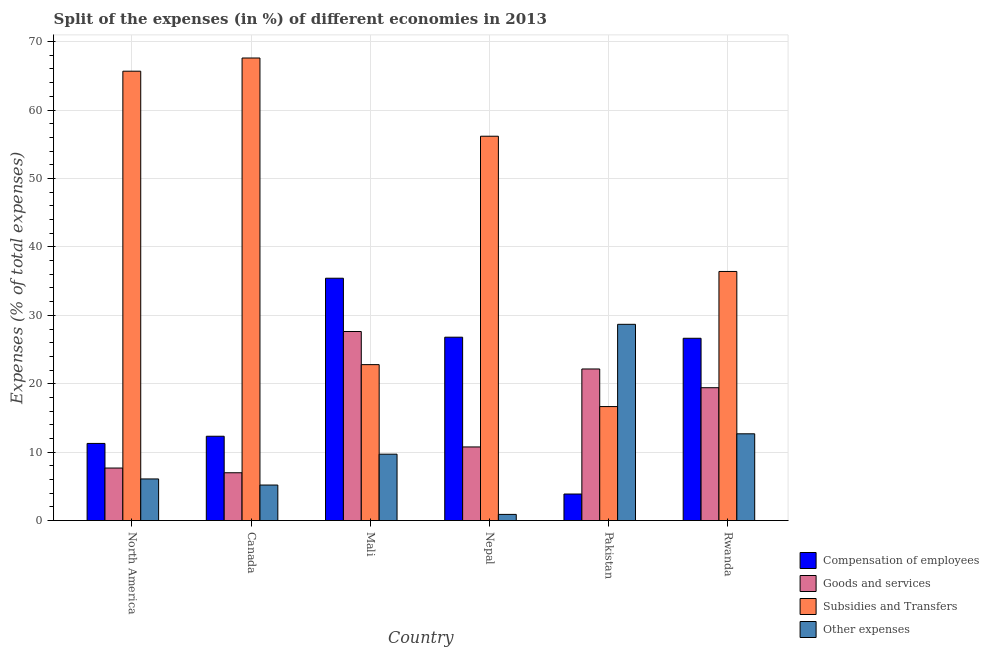How many different coloured bars are there?
Your response must be concise. 4. How many groups of bars are there?
Your response must be concise. 6. Are the number of bars per tick equal to the number of legend labels?
Offer a very short reply. Yes. How many bars are there on the 2nd tick from the left?
Provide a succinct answer. 4. In how many cases, is the number of bars for a given country not equal to the number of legend labels?
Provide a succinct answer. 0. What is the percentage of amount spent on subsidies in North America?
Your answer should be very brief. 65.68. Across all countries, what is the maximum percentage of amount spent on goods and services?
Your answer should be very brief. 27.63. Across all countries, what is the minimum percentage of amount spent on other expenses?
Make the answer very short. 0.9. In which country was the percentage of amount spent on compensation of employees maximum?
Offer a terse response. Mali. What is the total percentage of amount spent on other expenses in the graph?
Make the answer very short. 63.26. What is the difference between the percentage of amount spent on goods and services in Mali and that in North America?
Provide a short and direct response. 19.95. What is the difference between the percentage of amount spent on compensation of employees in Canada and the percentage of amount spent on subsidies in Pakistan?
Your response must be concise. -4.34. What is the average percentage of amount spent on goods and services per country?
Offer a very short reply. 15.77. What is the difference between the percentage of amount spent on other expenses and percentage of amount spent on compensation of employees in Canada?
Keep it short and to the point. -7.13. In how many countries, is the percentage of amount spent on goods and services greater than 46 %?
Your answer should be compact. 0. What is the ratio of the percentage of amount spent on goods and services in Canada to that in Pakistan?
Ensure brevity in your answer.  0.32. Is the difference between the percentage of amount spent on compensation of employees in Canada and Mali greater than the difference between the percentage of amount spent on goods and services in Canada and Mali?
Provide a succinct answer. No. What is the difference between the highest and the second highest percentage of amount spent on subsidies?
Provide a short and direct response. 1.93. What is the difference between the highest and the lowest percentage of amount spent on subsidies?
Make the answer very short. 50.94. Is the sum of the percentage of amount spent on other expenses in Mali and North America greater than the maximum percentage of amount spent on goods and services across all countries?
Give a very brief answer. No. Is it the case that in every country, the sum of the percentage of amount spent on compensation of employees and percentage of amount spent on other expenses is greater than the sum of percentage of amount spent on goods and services and percentage of amount spent on subsidies?
Your response must be concise. No. What does the 4th bar from the left in Rwanda represents?
Your answer should be compact. Other expenses. What does the 2nd bar from the right in Pakistan represents?
Your answer should be very brief. Subsidies and Transfers. Is it the case that in every country, the sum of the percentage of amount spent on compensation of employees and percentage of amount spent on goods and services is greater than the percentage of amount spent on subsidies?
Provide a succinct answer. No. Are all the bars in the graph horizontal?
Provide a succinct answer. No. What is the difference between two consecutive major ticks on the Y-axis?
Your answer should be very brief. 10. Does the graph contain any zero values?
Your response must be concise. No. How are the legend labels stacked?
Give a very brief answer. Vertical. What is the title of the graph?
Offer a terse response. Split of the expenses (in %) of different economies in 2013. What is the label or title of the X-axis?
Your response must be concise. Country. What is the label or title of the Y-axis?
Ensure brevity in your answer.  Expenses (% of total expenses). What is the Expenses (% of total expenses) of Compensation of employees in North America?
Offer a terse response. 11.28. What is the Expenses (% of total expenses) of Goods and services in North America?
Make the answer very short. 7.68. What is the Expenses (% of total expenses) in Subsidies and Transfers in North America?
Keep it short and to the point. 65.68. What is the Expenses (% of total expenses) of Other expenses in North America?
Provide a short and direct response. 6.09. What is the Expenses (% of total expenses) in Compensation of employees in Canada?
Your response must be concise. 12.33. What is the Expenses (% of total expenses) in Goods and services in Canada?
Keep it short and to the point. 6.99. What is the Expenses (% of total expenses) of Subsidies and Transfers in Canada?
Your answer should be very brief. 67.61. What is the Expenses (% of total expenses) in Other expenses in Canada?
Offer a terse response. 5.2. What is the Expenses (% of total expenses) of Compensation of employees in Mali?
Offer a terse response. 35.42. What is the Expenses (% of total expenses) in Goods and services in Mali?
Your response must be concise. 27.63. What is the Expenses (% of total expenses) of Subsidies and Transfers in Mali?
Keep it short and to the point. 22.79. What is the Expenses (% of total expenses) of Other expenses in Mali?
Make the answer very short. 9.71. What is the Expenses (% of total expenses) of Compensation of employees in Nepal?
Ensure brevity in your answer.  26.8. What is the Expenses (% of total expenses) of Goods and services in Nepal?
Provide a succinct answer. 10.76. What is the Expenses (% of total expenses) of Subsidies and Transfers in Nepal?
Offer a very short reply. 56.17. What is the Expenses (% of total expenses) of Other expenses in Nepal?
Your answer should be compact. 0.9. What is the Expenses (% of total expenses) of Compensation of employees in Pakistan?
Offer a terse response. 3.88. What is the Expenses (% of total expenses) of Goods and services in Pakistan?
Your response must be concise. 22.16. What is the Expenses (% of total expenses) in Subsidies and Transfers in Pakistan?
Offer a terse response. 16.66. What is the Expenses (% of total expenses) of Other expenses in Pakistan?
Your answer should be very brief. 28.68. What is the Expenses (% of total expenses) of Compensation of employees in Rwanda?
Provide a short and direct response. 26.64. What is the Expenses (% of total expenses) in Goods and services in Rwanda?
Keep it short and to the point. 19.42. What is the Expenses (% of total expenses) of Subsidies and Transfers in Rwanda?
Your answer should be very brief. 36.41. What is the Expenses (% of total expenses) of Other expenses in Rwanda?
Provide a short and direct response. 12.68. Across all countries, what is the maximum Expenses (% of total expenses) of Compensation of employees?
Offer a terse response. 35.42. Across all countries, what is the maximum Expenses (% of total expenses) of Goods and services?
Your answer should be compact. 27.63. Across all countries, what is the maximum Expenses (% of total expenses) in Subsidies and Transfers?
Your answer should be compact. 67.61. Across all countries, what is the maximum Expenses (% of total expenses) in Other expenses?
Your answer should be compact. 28.68. Across all countries, what is the minimum Expenses (% of total expenses) in Compensation of employees?
Keep it short and to the point. 3.88. Across all countries, what is the minimum Expenses (% of total expenses) in Goods and services?
Provide a succinct answer. 6.99. Across all countries, what is the minimum Expenses (% of total expenses) in Subsidies and Transfers?
Keep it short and to the point. 16.66. Across all countries, what is the minimum Expenses (% of total expenses) in Other expenses?
Give a very brief answer. 0.9. What is the total Expenses (% of total expenses) of Compensation of employees in the graph?
Your answer should be very brief. 116.36. What is the total Expenses (% of total expenses) of Goods and services in the graph?
Provide a succinct answer. 94.65. What is the total Expenses (% of total expenses) of Subsidies and Transfers in the graph?
Your response must be concise. 265.33. What is the total Expenses (% of total expenses) of Other expenses in the graph?
Your response must be concise. 63.26. What is the difference between the Expenses (% of total expenses) in Compensation of employees in North America and that in Canada?
Provide a short and direct response. -1.05. What is the difference between the Expenses (% of total expenses) in Goods and services in North America and that in Canada?
Offer a very short reply. 0.69. What is the difference between the Expenses (% of total expenses) of Subsidies and Transfers in North America and that in Canada?
Give a very brief answer. -1.93. What is the difference between the Expenses (% of total expenses) in Other expenses in North America and that in Canada?
Keep it short and to the point. 0.89. What is the difference between the Expenses (% of total expenses) in Compensation of employees in North America and that in Mali?
Your answer should be compact. -24.14. What is the difference between the Expenses (% of total expenses) of Goods and services in North America and that in Mali?
Offer a terse response. -19.95. What is the difference between the Expenses (% of total expenses) of Subsidies and Transfers in North America and that in Mali?
Offer a terse response. 42.89. What is the difference between the Expenses (% of total expenses) in Other expenses in North America and that in Mali?
Your response must be concise. -3.62. What is the difference between the Expenses (% of total expenses) in Compensation of employees in North America and that in Nepal?
Give a very brief answer. -15.53. What is the difference between the Expenses (% of total expenses) in Goods and services in North America and that in Nepal?
Ensure brevity in your answer.  -3.08. What is the difference between the Expenses (% of total expenses) in Subsidies and Transfers in North America and that in Nepal?
Your answer should be compact. 9.5. What is the difference between the Expenses (% of total expenses) in Other expenses in North America and that in Nepal?
Give a very brief answer. 5.18. What is the difference between the Expenses (% of total expenses) of Compensation of employees in North America and that in Pakistan?
Keep it short and to the point. 7.39. What is the difference between the Expenses (% of total expenses) of Goods and services in North America and that in Pakistan?
Your response must be concise. -14.48. What is the difference between the Expenses (% of total expenses) of Subsidies and Transfers in North America and that in Pakistan?
Provide a short and direct response. 49.01. What is the difference between the Expenses (% of total expenses) of Other expenses in North America and that in Pakistan?
Keep it short and to the point. -22.6. What is the difference between the Expenses (% of total expenses) in Compensation of employees in North America and that in Rwanda?
Make the answer very short. -15.37. What is the difference between the Expenses (% of total expenses) in Goods and services in North America and that in Rwanda?
Offer a terse response. -11.74. What is the difference between the Expenses (% of total expenses) of Subsidies and Transfers in North America and that in Rwanda?
Your answer should be very brief. 29.27. What is the difference between the Expenses (% of total expenses) in Other expenses in North America and that in Rwanda?
Provide a succinct answer. -6.6. What is the difference between the Expenses (% of total expenses) in Compensation of employees in Canada and that in Mali?
Make the answer very short. -23.09. What is the difference between the Expenses (% of total expenses) in Goods and services in Canada and that in Mali?
Your response must be concise. -20.64. What is the difference between the Expenses (% of total expenses) in Subsidies and Transfers in Canada and that in Mali?
Offer a terse response. 44.81. What is the difference between the Expenses (% of total expenses) in Other expenses in Canada and that in Mali?
Offer a very short reply. -4.51. What is the difference between the Expenses (% of total expenses) in Compensation of employees in Canada and that in Nepal?
Make the answer very short. -14.48. What is the difference between the Expenses (% of total expenses) of Goods and services in Canada and that in Nepal?
Your answer should be compact. -3.77. What is the difference between the Expenses (% of total expenses) of Subsidies and Transfers in Canada and that in Nepal?
Provide a succinct answer. 11.43. What is the difference between the Expenses (% of total expenses) in Other expenses in Canada and that in Nepal?
Your answer should be very brief. 4.29. What is the difference between the Expenses (% of total expenses) in Compensation of employees in Canada and that in Pakistan?
Give a very brief answer. 8.44. What is the difference between the Expenses (% of total expenses) in Goods and services in Canada and that in Pakistan?
Provide a succinct answer. -15.17. What is the difference between the Expenses (% of total expenses) in Subsidies and Transfers in Canada and that in Pakistan?
Provide a short and direct response. 50.94. What is the difference between the Expenses (% of total expenses) of Other expenses in Canada and that in Pakistan?
Provide a succinct answer. -23.49. What is the difference between the Expenses (% of total expenses) in Compensation of employees in Canada and that in Rwanda?
Your answer should be very brief. -14.32. What is the difference between the Expenses (% of total expenses) of Goods and services in Canada and that in Rwanda?
Give a very brief answer. -12.43. What is the difference between the Expenses (% of total expenses) in Subsidies and Transfers in Canada and that in Rwanda?
Offer a terse response. 31.2. What is the difference between the Expenses (% of total expenses) of Other expenses in Canada and that in Rwanda?
Offer a very short reply. -7.49. What is the difference between the Expenses (% of total expenses) of Compensation of employees in Mali and that in Nepal?
Offer a terse response. 8.62. What is the difference between the Expenses (% of total expenses) of Goods and services in Mali and that in Nepal?
Make the answer very short. 16.87. What is the difference between the Expenses (% of total expenses) of Subsidies and Transfers in Mali and that in Nepal?
Your answer should be compact. -33.38. What is the difference between the Expenses (% of total expenses) of Other expenses in Mali and that in Nepal?
Make the answer very short. 8.8. What is the difference between the Expenses (% of total expenses) in Compensation of employees in Mali and that in Pakistan?
Your response must be concise. 31.54. What is the difference between the Expenses (% of total expenses) in Goods and services in Mali and that in Pakistan?
Your answer should be compact. 5.48. What is the difference between the Expenses (% of total expenses) of Subsidies and Transfers in Mali and that in Pakistan?
Provide a short and direct response. 6.13. What is the difference between the Expenses (% of total expenses) of Other expenses in Mali and that in Pakistan?
Your answer should be very brief. -18.98. What is the difference between the Expenses (% of total expenses) of Compensation of employees in Mali and that in Rwanda?
Ensure brevity in your answer.  8.78. What is the difference between the Expenses (% of total expenses) of Goods and services in Mali and that in Rwanda?
Make the answer very short. 8.21. What is the difference between the Expenses (% of total expenses) in Subsidies and Transfers in Mali and that in Rwanda?
Offer a terse response. -13.62. What is the difference between the Expenses (% of total expenses) of Other expenses in Mali and that in Rwanda?
Offer a terse response. -2.98. What is the difference between the Expenses (% of total expenses) of Compensation of employees in Nepal and that in Pakistan?
Ensure brevity in your answer.  22.92. What is the difference between the Expenses (% of total expenses) in Goods and services in Nepal and that in Pakistan?
Your response must be concise. -11.39. What is the difference between the Expenses (% of total expenses) of Subsidies and Transfers in Nepal and that in Pakistan?
Your response must be concise. 39.51. What is the difference between the Expenses (% of total expenses) in Other expenses in Nepal and that in Pakistan?
Provide a succinct answer. -27.78. What is the difference between the Expenses (% of total expenses) in Compensation of employees in Nepal and that in Rwanda?
Give a very brief answer. 0.16. What is the difference between the Expenses (% of total expenses) of Goods and services in Nepal and that in Rwanda?
Provide a short and direct response. -8.66. What is the difference between the Expenses (% of total expenses) of Subsidies and Transfers in Nepal and that in Rwanda?
Make the answer very short. 19.77. What is the difference between the Expenses (% of total expenses) of Other expenses in Nepal and that in Rwanda?
Provide a short and direct response. -11.78. What is the difference between the Expenses (% of total expenses) of Compensation of employees in Pakistan and that in Rwanda?
Your answer should be compact. -22.76. What is the difference between the Expenses (% of total expenses) of Goods and services in Pakistan and that in Rwanda?
Give a very brief answer. 2.74. What is the difference between the Expenses (% of total expenses) of Subsidies and Transfers in Pakistan and that in Rwanda?
Make the answer very short. -19.74. What is the difference between the Expenses (% of total expenses) of Other expenses in Pakistan and that in Rwanda?
Ensure brevity in your answer.  16. What is the difference between the Expenses (% of total expenses) in Compensation of employees in North America and the Expenses (% of total expenses) in Goods and services in Canada?
Keep it short and to the point. 4.29. What is the difference between the Expenses (% of total expenses) of Compensation of employees in North America and the Expenses (% of total expenses) of Subsidies and Transfers in Canada?
Ensure brevity in your answer.  -56.33. What is the difference between the Expenses (% of total expenses) of Compensation of employees in North America and the Expenses (% of total expenses) of Other expenses in Canada?
Offer a very short reply. 6.08. What is the difference between the Expenses (% of total expenses) in Goods and services in North America and the Expenses (% of total expenses) in Subsidies and Transfers in Canada?
Offer a very short reply. -59.92. What is the difference between the Expenses (% of total expenses) of Goods and services in North America and the Expenses (% of total expenses) of Other expenses in Canada?
Ensure brevity in your answer.  2.48. What is the difference between the Expenses (% of total expenses) in Subsidies and Transfers in North America and the Expenses (% of total expenses) in Other expenses in Canada?
Give a very brief answer. 60.48. What is the difference between the Expenses (% of total expenses) of Compensation of employees in North America and the Expenses (% of total expenses) of Goods and services in Mali?
Your answer should be compact. -16.36. What is the difference between the Expenses (% of total expenses) in Compensation of employees in North America and the Expenses (% of total expenses) in Subsidies and Transfers in Mali?
Your response must be concise. -11.51. What is the difference between the Expenses (% of total expenses) in Compensation of employees in North America and the Expenses (% of total expenses) in Other expenses in Mali?
Make the answer very short. 1.57. What is the difference between the Expenses (% of total expenses) of Goods and services in North America and the Expenses (% of total expenses) of Subsidies and Transfers in Mali?
Give a very brief answer. -15.11. What is the difference between the Expenses (% of total expenses) in Goods and services in North America and the Expenses (% of total expenses) in Other expenses in Mali?
Give a very brief answer. -2.02. What is the difference between the Expenses (% of total expenses) of Subsidies and Transfers in North America and the Expenses (% of total expenses) of Other expenses in Mali?
Ensure brevity in your answer.  55.97. What is the difference between the Expenses (% of total expenses) in Compensation of employees in North America and the Expenses (% of total expenses) in Goods and services in Nepal?
Make the answer very short. 0.51. What is the difference between the Expenses (% of total expenses) in Compensation of employees in North America and the Expenses (% of total expenses) in Subsidies and Transfers in Nepal?
Ensure brevity in your answer.  -44.9. What is the difference between the Expenses (% of total expenses) of Compensation of employees in North America and the Expenses (% of total expenses) of Other expenses in Nepal?
Your answer should be very brief. 10.37. What is the difference between the Expenses (% of total expenses) in Goods and services in North America and the Expenses (% of total expenses) in Subsidies and Transfers in Nepal?
Ensure brevity in your answer.  -48.49. What is the difference between the Expenses (% of total expenses) of Goods and services in North America and the Expenses (% of total expenses) of Other expenses in Nepal?
Make the answer very short. 6.78. What is the difference between the Expenses (% of total expenses) of Subsidies and Transfers in North America and the Expenses (% of total expenses) of Other expenses in Nepal?
Ensure brevity in your answer.  64.77. What is the difference between the Expenses (% of total expenses) of Compensation of employees in North America and the Expenses (% of total expenses) of Goods and services in Pakistan?
Make the answer very short. -10.88. What is the difference between the Expenses (% of total expenses) in Compensation of employees in North America and the Expenses (% of total expenses) in Subsidies and Transfers in Pakistan?
Provide a short and direct response. -5.39. What is the difference between the Expenses (% of total expenses) in Compensation of employees in North America and the Expenses (% of total expenses) in Other expenses in Pakistan?
Your answer should be compact. -17.41. What is the difference between the Expenses (% of total expenses) of Goods and services in North America and the Expenses (% of total expenses) of Subsidies and Transfers in Pakistan?
Your response must be concise. -8.98. What is the difference between the Expenses (% of total expenses) of Goods and services in North America and the Expenses (% of total expenses) of Other expenses in Pakistan?
Your response must be concise. -21. What is the difference between the Expenses (% of total expenses) in Subsidies and Transfers in North America and the Expenses (% of total expenses) in Other expenses in Pakistan?
Make the answer very short. 36.99. What is the difference between the Expenses (% of total expenses) of Compensation of employees in North America and the Expenses (% of total expenses) of Goods and services in Rwanda?
Offer a very short reply. -8.14. What is the difference between the Expenses (% of total expenses) in Compensation of employees in North America and the Expenses (% of total expenses) in Subsidies and Transfers in Rwanda?
Give a very brief answer. -25.13. What is the difference between the Expenses (% of total expenses) in Compensation of employees in North America and the Expenses (% of total expenses) in Other expenses in Rwanda?
Keep it short and to the point. -1.41. What is the difference between the Expenses (% of total expenses) in Goods and services in North America and the Expenses (% of total expenses) in Subsidies and Transfers in Rwanda?
Provide a short and direct response. -28.73. What is the difference between the Expenses (% of total expenses) in Goods and services in North America and the Expenses (% of total expenses) in Other expenses in Rwanda?
Give a very brief answer. -5. What is the difference between the Expenses (% of total expenses) of Subsidies and Transfers in North America and the Expenses (% of total expenses) of Other expenses in Rwanda?
Give a very brief answer. 53. What is the difference between the Expenses (% of total expenses) in Compensation of employees in Canada and the Expenses (% of total expenses) in Goods and services in Mali?
Provide a short and direct response. -15.31. What is the difference between the Expenses (% of total expenses) of Compensation of employees in Canada and the Expenses (% of total expenses) of Subsidies and Transfers in Mali?
Offer a very short reply. -10.46. What is the difference between the Expenses (% of total expenses) of Compensation of employees in Canada and the Expenses (% of total expenses) of Other expenses in Mali?
Your response must be concise. 2.62. What is the difference between the Expenses (% of total expenses) of Goods and services in Canada and the Expenses (% of total expenses) of Subsidies and Transfers in Mali?
Offer a very short reply. -15.8. What is the difference between the Expenses (% of total expenses) in Goods and services in Canada and the Expenses (% of total expenses) in Other expenses in Mali?
Your response must be concise. -2.71. What is the difference between the Expenses (% of total expenses) in Subsidies and Transfers in Canada and the Expenses (% of total expenses) in Other expenses in Mali?
Provide a short and direct response. 57.9. What is the difference between the Expenses (% of total expenses) of Compensation of employees in Canada and the Expenses (% of total expenses) of Goods and services in Nepal?
Provide a succinct answer. 1.56. What is the difference between the Expenses (% of total expenses) of Compensation of employees in Canada and the Expenses (% of total expenses) of Subsidies and Transfers in Nepal?
Your answer should be very brief. -43.85. What is the difference between the Expenses (% of total expenses) of Compensation of employees in Canada and the Expenses (% of total expenses) of Other expenses in Nepal?
Your answer should be compact. 11.42. What is the difference between the Expenses (% of total expenses) in Goods and services in Canada and the Expenses (% of total expenses) in Subsidies and Transfers in Nepal?
Make the answer very short. -49.18. What is the difference between the Expenses (% of total expenses) of Goods and services in Canada and the Expenses (% of total expenses) of Other expenses in Nepal?
Your answer should be very brief. 6.09. What is the difference between the Expenses (% of total expenses) in Subsidies and Transfers in Canada and the Expenses (% of total expenses) in Other expenses in Nepal?
Provide a short and direct response. 66.7. What is the difference between the Expenses (% of total expenses) in Compensation of employees in Canada and the Expenses (% of total expenses) in Goods and services in Pakistan?
Offer a very short reply. -9.83. What is the difference between the Expenses (% of total expenses) of Compensation of employees in Canada and the Expenses (% of total expenses) of Subsidies and Transfers in Pakistan?
Your answer should be very brief. -4.34. What is the difference between the Expenses (% of total expenses) in Compensation of employees in Canada and the Expenses (% of total expenses) in Other expenses in Pakistan?
Provide a succinct answer. -16.36. What is the difference between the Expenses (% of total expenses) in Goods and services in Canada and the Expenses (% of total expenses) in Subsidies and Transfers in Pakistan?
Your response must be concise. -9.67. What is the difference between the Expenses (% of total expenses) in Goods and services in Canada and the Expenses (% of total expenses) in Other expenses in Pakistan?
Offer a terse response. -21.69. What is the difference between the Expenses (% of total expenses) in Subsidies and Transfers in Canada and the Expenses (% of total expenses) in Other expenses in Pakistan?
Provide a short and direct response. 38.92. What is the difference between the Expenses (% of total expenses) in Compensation of employees in Canada and the Expenses (% of total expenses) in Goods and services in Rwanda?
Your answer should be compact. -7.09. What is the difference between the Expenses (% of total expenses) in Compensation of employees in Canada and the Expenses (% of total expenses) in Subsidies and Transfers in Rwanda?
Provide a short and direct response. -24.08. What is the difference between the Expenses (% of total expenses) in Compensation of employees in Canada and the Expenses (% of total expenses) in Other expenses in Rwanda?
Provide a succinct answer. -0.36. What is the difference between the Expenses (% of total expenses) of Goods and services in Canada and the Expenses (% of total expenses) of Subsidies and Transfers in Rwanda?
Give a very brief answer. -29.42. What is the difference between the Expenses (% of total expenses) of Goods and services in Canada and the Expenses (% of total expenses) of Other expenses in Rwanda?
Ensure brevity in your answer.  -5.69. What is the difference between the Expenses (% of total expenses) in Subsidies and Transfers in Canada and the Expenses (% of total expenses) in Other expenses in Rwanda?
Keep it short and to the point. 54.92. What is the difference between the Expenses (% of total expenses) of Compensation of employees in Mali and the Expenses (% of total expenses) of Goods and services in Nepal?
Ensure brevity in your answer.  24.66. What is the difference between the Expenses (% of total expenses) in Compensation of employees in Mali and the Expenses (% of total expenses) in Subsidies and Transfers in Nepal?
Your answer should be very brief. -20.75. What is the difference between the Expenses (% of total expenses) in Compensation of employees in Mali and the Expenses (% of total expenses) in Other expenses in Nepal?
Provide a short and direct response. 34.52. What is the difference between the Expenses (% of total expenses) in Goods and services in Mali and the Expenses (% of total expenses) in Subsidies and Transfers in Nepal?
Make the answer very short. -28.54. What is the difference between the Expenses (% of total expenses) in Goods and services in Mali and the Expenses (% of total expenses) in Other expenses in Nepal?
Provide a succinct answer. 26.73. What is the difference between the Expenses (% of total expenses) of Subsidies and Transfers in Mali and the Expenses (% of total expenses) of Other expenses in Nepal?
Your response must be concise. 21.89. What is the difference between the Expenses (% of total expenses) in Compensation of employees in Mali and the Expenses (% of total expenses) in Goods and services in Pakistan?
Ensure brevity in your answer.  13.26. What is the difference between the Expenses (% of total expenses) of Compensation of employees in Mali and the Expenses (% of total expenses) of Subsidies and Transfers in Pakistan?
Make the answer very short. 18.76. What is the difference between the Expenses (% of total expenses) of Compensation of employees in Mali and the Expenses (% of total expenses) of Other expenses in Pakistan?
Your response must be concise. 6.74. What is the difference between the Expenses (% of total expenses) of Goods and services in Mali and the Expenses (% of total expenses) of Subsidies and Transfers in Pakistan?
Your answer should be very brief. 10.97. What is the difference between the Expenses (% of total expenses) in Goods and services in Mali and the Expenses (% of total expenses) in Other expenses in Pakistan?
Provide a short and direct response. -1.05. What is the difference between the Expenses (% of total expenses) of Subsidies and Transfers in Mali and the Expenses (% of total expenses) of Other expenses in Pakistan?
Keep it short and to the point. -5.89. What is the difference between the Expenses (% of total expenses) in Compensation of employees in Mali and the Expenses (% of total expenses) in Goods and services in Rwanda?
Give a very brief answer. 16. What is the difference between the Expenses (% of total expenses) in Compensation of employees in Mali and the Expenses (% of total expenses) in Subsidies and Transfers in Rwanda?
Your response must be concise. -0.99. What is the difference between the Expenses (% of total expenses) in Compensation of employees in Mali and the Expenses (% of total expenses) in Other expenses in Rwanda?
Offer a very short reply. 22.74. What is the difference between the Expenses (% of total expenses) of Goods and services in Mali and the Expenses (% of total expenses) of Subsidies and Transfers in Rwanda?
Provide a succinct answer. -8.78. What is the difference between the Expenses (% of total expenses) of Goods and services in Mali and the Expenses (% of total expenses) of Other expenses in Rwanda?
Make the answer very short. 14.95. What is the difference between the Expenses (% of total expenses) in Subsidies and Transfers in Mali and the Expenses (% of total expenses) in Other expenses in Rwanda?
Offer a terse response. 10.11. What is the difference between the Expenses (% of total expenses) of Compensation of employees in Nepal and the Expenses (% of total expenses) of Goods and services in Pakistan?
Provide a short and direct response. 4.65. What is the difference between the Expenses (% of total expenses) of Compensation of employees in Nepal and the Expenses (% of total expenses) of Subsidies and Transfers in Pakistan?
Ensure brevity in your answer.  10.14. What is the difference between the Expenses (% of total expenses) of Compensation of employees in Nepal and the Expenses (% of total expenses) of Other expenses in Pakistan?
Your answer should be very brief. -1.88. What is the difference between the Expenses (% of total expenses) of Goods and services in Nepal and the Expenses (% of total expenses) of Subsidies and Transfers in Pakistan?
Make the answer very short. -5.9. What is the difference between the Expenses (% of total expenses) of Goods and services in Nepal and the Expenses (% of total expenses) of Other expenses in Pakistan?
Give a very brief answer. -17.92. What is the difference between the Expenses (% of total expenses) of Subsidies and Transfers in Nepal and the Expenses (% of total expenses) of Other expenses in Pakistan?
Ensure brevity in your answer.  27.49. What is the difference between the Expenses (% of total expenses) of Compensation of employees in Nepal and the Expenses (% of total expenses) of Goods and services in Rwanda?
Provide a succinct answer. 7.38. What is the difference between the Expenses (% of total expenses) of Compensation of employees in Nepal and the Expenses (% of total expenses) of Subsidies and Transfers in Rwanda?
Your answer should be very brief. -9.61. What is the difference between the Expenses (% of total expenses) of Compensation of employees in Nepal and the Expenses (% of total expenses) of Other expenses in Rwanda?
Your response must be concise. 14.12. What is the difference between the Expenses (% of total expenses) of Goods and services in Nepal and the Expenses (% of total expenses) of Subsidies and Transfers in Rwanda?
Your answer should be compact. -25.65. What is the difference between the Expenses (% of total expenses) in Goods and services in Nepal and the Expenses (% of total expenses) in Other expenses in Rwanda?
Make the answer very short. -1.92. What is the difference between the Expenses (% of total expenses) of Subsidies and Transfers in Nepal and the Expenses (% of total expenses) of Other expenses in Rwanda?
Your response must be concise. 43.49. What is the difference between the Expenses (% of total expenses) in Compensation of employees in Pakistan and the Expenses (% of total expenses) in Goods and services in Rwanda?
Offer a very short reply. -15.54. What is the difference between the Expenses (% of total expenses) of Compensation of employees in Pakistan and the Expenses (% of total expenses) of Subsidies and Transfers in Rwanda?
Your answer should be compact. -32.53. What is the difference between the Expenses (% of total expenses) in Compensation of employees in Pakistan and the Expenses (% of total expenses) in Other expenses in Rwanda?
Offer a very short reply. -8.8. What is the difference between the Expenses (% of total expenses) of Goods and services in Pakistan and the Expenses (% of total expenses) of Subsidies and Transfers in Rwanda?
Your answer should be compact. -14.25. What is the difference between the Expenses (% of total expenses) of Goods and services in Pakistan and the Expenses (% of total expenses) of Other expenses in Rwanda?
Your response must be concise. 9.47. What is the difference between the Expenses (% of total expenses) in Subsidies and Transfers in Pakistan and the Expenses (% of total expenses) in Other expenses in Rwanda?
Provide a succinct answer. 3.98. What is the average Expenses (% of total expenses) in Compensation of employees per country?
Your answer should be very brief. 19.39. What is the average Expenses (% of total expenses) of Goods and services per country?
Ensure brevity in your answer.  15.77. What is the average Expenses (% of total expenses) in Subsidies and Transfers per country?
Offer a terse response. 44.22. What is the average Expenses (% of total expenses) in Other expenses per country?
Your answer should be very brief. 10.54. What is the difference between the Expenses (% of total expenses) in Compensation of employees and Expenses (% of total expenses) in Goods and services in North America?
Make the answer very short. 3.6. What is the difference between the Expenses (% of total expenses) of Compensation of employees and Expenses (% of total expenses) of Subsidies and Transfers in North America?
Provide a short and direct response. -54.4. What is the difference between the Expenses (% of total expenses) in Compensation of employees and Expenses (% of total expenses) in Other expenses in North America?
Ensure brevity in your answer.  5.19. What is the difference between the Expenses (% of total expenses) of Goods and services and Expenses (% of total expenses) of Subsidies and Transfers in North America?
Your answer should be very brief. -58. What is the difference between the Expenses (% of total expenses) in Goods and services and Expenses (% of total expenses) in Other expenses in North America?
Your answer should be very brief. 1.59. What is the difference between the Expenses (% of total expenses) of Subsidies and Transfers and Expenses (% of total expenses) of Other expenses in North America?
Provide a succinct answer. 59.59. What is the difference between the Expenses (% of total expenses) in Compensation of employees and Expenses (% of total expenses) in Goods and services in Canada?
Your answer should be compact. 5.34. What is the difference between the Expenses (% of total expenses) of Compensation of employees and Expenses (% of total expenses) of Subsidies and Transfers in Canada?
Your response must be concise. -55.28. What is the difference between the Expenses (% of total expenses) of Compensation of employees and Expenses (% of total expenses) of Other expenses in Canada?
Offer a very short reply. 7.13. What is the difference between the Expenses (% of total expenses) in Goods and services and Expenses (% of total expenses) in Subsidies and Transfers in Canada?
Offer a terse response. -60.61. What is the difference between the Expenses (% of total expenses) in Goods and services and Expenses (% of total expenses) in Other expenses in Canada?
Your answer should be compact. 1.8. What is the difference between the Expenses (% of total expenses) of Subsidies and Transfers and Expenses (% of total expenses) of Other expenses in Canada?
Offer a terse response. 62.41. What is the difference between the Expenses (% of total expenses) in Compensation of employees and Expenses (% of total expenses) in Goods and services in Mali?
Offer a very short reply. 7.79. What is the difference between the Expenses (% of total expenses) in Compensation of employees and Expenses (% of total expenses) in Subsidies and Transfers in Mali?
Offer a very short reply. 12.63. What is the difference between the Expenses (% of total expenses) in Compensation of employees and Expenses (% of total expenses) in Other expenses in Mali?
Provide a short and direct response. 25.71. What is the difference between the Expenses (% of total expenses) of Goods and services and Expenses (% of total expenses) of Subsidies and Transfers in Mali?
Offer a terse response. 4.84. What is the difference between the Expenses (% of total expenses) in Goods and services and Expenses (% of total expenses) in Other expenses in Mali?
Provide a short and direct response. 17.93. What is the difference between the Expenses (% of total expenses) in Subsidies and Transfers and Expenses (% of total expenses) in Other expenses in Mali?
Your answer should be compact. 13.09. What is the difference between the Expenses (% of total expenses) in Compensation of employees and Expenses (% of total expenses) in Goods and services in Nepal?
Your response must be concise. 16.04. What is the difference between the Expenses (% of total expenses) of Compensation of employees and Expenses (% of total expenses) of Subsidies and Transfers in Nepal?
Your response must be concise. -29.37. What is the difference between the Expenses (% of total expenses) of Compensation of employees and Expenses (% of total expenses) of Other expenses in Nepal?
Provide a short and direct response. 25.9. What is the difference between the Expenses (% of total expenses) in Goods and services and Expenses (% of total expenses) in Subsidies and Transfers in Nepal?
Give a very brief answer. -45.41. What is the difference between the Expenses (% of total expenses) in Goods and services and Expenses (% of total expenses) in Other expenses in Nepal?
Give a very brief answer. 9.86. What is the difference between the Expenses (% of total expenses) in Subsidies and Transfers and Expenses (% of total expenses) in Other expenses in Nepal?
Keep it short and to the point. 55.27. What is the difference between the Expenses (% of total expenses) in Compensation of employees and Expenses (% of total expenses) in Goods and services in Pakistan?
Provide a succinct answer. -18.27. What is the difference between the Expenses (% of total expenses) in Compensation of employees and Expenses (% of total expenses) in Subsidies and Transfers in Pakistan?
Provide a short and direct response. -12.78. What is the difference between the Expenses (% of total expenses) of Compensation of employees and Expenses (% of total expenses) of Other expenses in Pakistan?
Your response must be concise. -24.8. What is the difference between the Expenses (% of total expenses) in Goods and services and Expenses (% of total expenses) in Subsidies and Transfers in Pakistan?
Provide a succinct answer. 5.49. What is the difference between the Expenses (% of total expenses) in Goods and services and Expenses (% of total expenses) in Other expenses in Pakistan?
Provide a short and direct response. -6.53. What is the difference between the Expenses (% of total expenses) in Subsidies and Transfers and Expenses (% of total expenses) in Other expenses in Pakistan?
Your answer should be very brief. -12.02. What is the difference between the Expenses (% of total expenses) of Compensation of employees and Expenses (% of total expenses) of Goods and services in Rwanda?
Your response must be concise. 7.23. What is the difference between the Expenses (% of total expenses) in Compensation of employees and Expenses (% of total expenses) in Subsidies and Transfers in Rwanda?
Your answer should be compact. -9.76. What is the difference between the Expenses (% of total expenses) of Compensation of employees and Expenses (% of total expenses) of Other expenses in Rwanda?
Your answer should be compact. 13.96. What is the difference between the Expenses (% of total expenses) in Goods and services and Expenses (% of total expenses) in Subsidies and Transfers in Rwanda?
Ensure brevity in your answer.  -16.99. What is the difference between the Expenses (% of total expenses) of Goods and services and Expenses (% of total expenses) of Other expenses in Rwanda?
Offer a terse response. 6.74. What is the difference between the Expenses (% of total expenses) in Subsidies and Transfers and Expenses (% of total expenses) in Other expenses in Rwanda?
Provide a succinct answer. 23.73. What is the ratio of the Expenses (% of total expenses) in Compensation of employees in North America to that in Canada?
Provide a succinct answer. 0.91. What is the ratio of the Expenses (% of total expenses) of Goods and services in North America to that in Canada?
Your answer should be very brief. 1.1. What is the ratio of the Expenses (% of total expenses) of Subsidies and Transfers in North America to that in Canada?
Provide a succinct answer. 0.97. What is the ratio of the Expenses (% of total expenses) of Other expenses in North America to that in Canada?
Give a very brief answer. 1.17. What is the ratio of the Expenses (% of total expenses) of Compensation of employees in North America to that in Mali?
Your response must be concise. 0.32. What is the ratio of the Expenses (% of total expenses) of Goods and services in North America to that in Mali?
Provide a succinct answer. 0.28. What is the ratio of the Expenses (% of total expenses) in Subsidies and Transfers in North America to that in Mali?
Offer a very short reply. 2.88. What is the ratio of the Expenses (% of total expenses) in Other expenses in North America to that in Mali?
Give a very brief answer. 0.63. What is the ratio of the Expenses (% of total expenses) in Compensation of employees in North America to that in Nepal?
Your answer should be compact. 0.42. What is the ratio of the Expenses (% of total expenses) of Goods and services in North America to that in Nepal?
Your answer should be compact. 0.71. What is the ratio of the Expenses (% of total expenses) of Subsidies and Transfers in North America to that in Nepal?
Give a very brief answer. 1.17. What is the ratio of the Expenses (% of total expenses) of Other expenses in North America to that in Nepal?
Ensure brevity in your answer.  6.73. What is the ratio of the Expenses (% of total expenses) of Compensation of employees in North America to that in Pakistan?
Keep it short and to the point. 2.9. What is the ratio of the Expenses (% of total expenses) of Goods and services in North America to that in Pakistan?
Offer a very short reply. 0.35. What is the ratio of the Expenses (% of total expenses) in Subsidies and Transfers in North America to that in Pakistan?
Provide a short and direct response. 3.94. What is the ratio of the Expenses (% of total expenses) of Other expenses in North America to that in Pakistan?
Provide a succinct answer. 0.21. What is the ratio of the Expenses (% of total expenses) in Compensation of employees in North America to that in Rwanda?
Your answer should be very brief. 0.42. What is the ratio of the Expenses (% of total expenses) in Goods and services in North America to that in Rwanda?
Provide a succinct answer. 0.4. What is the ratio of the Expenses (% of total expenses) of Subsidies and Transfers in North America to that in Rwanda?
Keep it short and to the point. 1.8. What is the ratio of the Expenses (% of total expenses) of Other expenses in North America to that in Rwanda?
Provide a short and direct response. 0.48. What is the ratio of the Expenses (% of total expenses) of Compensation of employees in Canada to that in Mali?
Your response must be concise. 0.35. What is the ratio of the Expenses (% of total expenses) of Goods and services in Canada to that in Mali?
Offer a terse response. 0.25. What is the ratio of the Expenses (% of total expenses) in Subsidies and Transfers in Canada to that in Mali?
Provide a short and direct response. 2.97. What is the ratio of the Expenses (% of total expenses) of Other expenses in Canada to that in Mali?
Your answer should be compact. 0.54. What is the ratio of the Expenses (% of total expenses) in Compensation of employees in Canada to that in Nepal?
Provide a succinct answer. 0.46. What is the ratio of the Expenses (% of total expenses) in Goods and services in Canada to that in Nepal?
Your answer should be very brief. 0.65. What is the ratio of the Expenses (% of total expenses) of Subsidies and Transfers in Canada to that in Nepal?
Offer a terse response. 1.2. What is the ratio of the Expenses (% of total expenses) of Other expenses in Canada to that in Nepal?
Provide a succinct answer. 5.74. What is the ratio of the Expenses (% of total expenses) of Compensation of employees in Canada to that in Pakistan?
Your answer should be very brief. 3.17. What is the ratio of the Expenses (% of total expenses) in Goods and services in Canada to that in Pakistan?
Your answer should be compact. 0.32. What is the ratio of the Expenses (% of total expenses) in Subsidies and Transfers in Canada to that in Pakistan?
Your response must be concise. 4.06. What is the ratio of the Expenses (% of total expenses) in Other expenses in Canada to that in Pakistan?
Your answer should be very brief. 0.18. What is the ratio of the Expenses (% of total expenses) in Compensation of employees in Canada to that in Rwanda?
Provide a short and direct response. 0.46. What is the ratio of the Expenses (% of total expenses) in Goods and services in Canada to that in Rwanda?
Keep it short and to the point. 0.36. What is the ratio of the Expenses (% of total expenses) in Subsidies and Transfers in Canada to that in Rwanda?
Your answer should be compact. 1.86. What is the ratio of the Expenses (% of total expenses) in Other expenses in Canada to that in Rwanda?
Keep it short and to the point. 0.41. What is the ratio of the Expenses (% of total expenses) in Compensation of employees in Mali to that in Nepal?
Ensure brevity in your answer.  1.32. What is the ratio of the Expenses (% of total expenses) in Goods and services in Mali to that in Nepal?
Give a very brief answer. 2.57. What is the ratio of the Expenses (% of total expenses) of Subsidies and Transfers in Mali to that in Nepal?
Make the answer very short. 0.41. What is the ratio of the Expenses (% of total expenses) of Other expenses in Mali to that in Nepal?
Make the answer very short. 10.73. What is the ratio of the Expenses (% of total expenses) of Compensation of employees in Mali to that in Pakistan?
Provide a short and direct response. 9.12. What is the ratio of the Expenses (% of total expenses) of Goods and services in Mali to that in Pakistan?
Your answer should be compact. 1.25. What is the ratio of the Expenses (% of total expenses) in Subsidies and Transfers in Mali to that in Pakistan?
Provide a succinct answer. 1.37. What is the ratio of the Expenses (% of total expenses) in Other expenses in Mali to that in Pakistan?
Offer a very short reply. 0.34. What is the ratio of the Expenses (% of total expenses) in Compensation of employees in Mali to that in Rwanda?
Offer a terse response. 1.33. What is the ratio of the Expenses (% of total expenses) in Goods and services in Mali to that in Rwanda?
Offer a terse response. 1.42. What is the ratio of the Expenses (% of total expenses) of Subsidies and Transfers in Mali to that in Rwanda?
Your answer should be compact. 0.63. What is the ratio of the Expenses (% of total expenses) in Other expenses in Mali to that in Rwanda?
Provide a succinct answer. 0.77. What is the ratio of the Expenses (% of total expenses) in Compensation of employees in Nepal to that in Pakistan?
Provide a succinct answer. 6.9. What is the ratio of the Expenses (% of total expenses) of Goods and services in Nepal to that in Pakistan?
Keep it short and to the point. 0.49. What is the ratio of the Expenses (% of total expenses) of Subsidies and Transfers in Nepal to that in Pakistan?
Give a very brief answer. 3.37. What is the ratio of the Expenses (% of total expenses) of Other expenses in Nepal to that in Pakistan?
Your response must be concise. 0.03. What is the ratio of the Expenses (% of total expenses) of Compensation of employees in Nepal to that in Rwanda?
Offer a very short reply. 1.01. What is the ratio of the Expenses (% of total expenses) in Goods and services in Nepal to that in Rwanda?
Offer a very short reply. 0.55. What is the ratio of the Expenses (% of total expenses) in Subsidies and Transfers in Nepal to that in Rwanda?
Provide a short and direct response. 1.54. What is the ratio of the Expenses (% of total expenses) of Other expenses in Nepal to that in Rwanda?
Ensure brevity in your answer.  0.07. What is the ratio of the Expenses (% of total expenses) in Compensation of employees in Pakistan to that in Rwanda?
Offer a very short reply. 0.15. What is the ratio of the Expenses (% of total expenses) of Goods and services in Pakistan to that in Rwanda?
Your answer should be compact. 1.14. What is the ratio of the Expenses (% of total expenses) in Subsidies and Transfers in Pakistan to that in Rwanda?
Offer a very short reply. 0.46. What is the ratio of the Expenses (% of total expenses) in Other expenses in Pakistan to that in Rwanda?
Offer a very short reply. 2.26. What is the difference between the highest and the second highest Expenses (% of total expenses) in Compensation of employees?
Your answer should be compact. 8.62. What is the difference between the highest and the second highest Expenses (% of total expenses) of Goods and services?
Your response must be concise. 5.48. What is the difference between the highest and the second highest Expenses (% of total expenses) in Subsidies and Transfers?
Your answer should be compact. 1.93. What is the difference between the highest and the second highest Expenses (% of total expenses) of Other expenses?
Keep it short and to the point. 16. What is the difference between the highest and the lowest Expenses (% of total expenses) of Compensation of employees?
Your response must be concise. 31.54. What is the difference between the highest and the lowest Expenses (% of total expenses) of Goods and services?
Keep it short and to the point. 20.64. What is the difference between the highest and the lowest Expenses (% of total expenses) of Subsidies and Transfers?
Offer a very short reply. 50.94. What is the difference between the highest and the lowest Expenses (% of total expenses) in Other expenses?
Your answer should be compact. 27.78. 